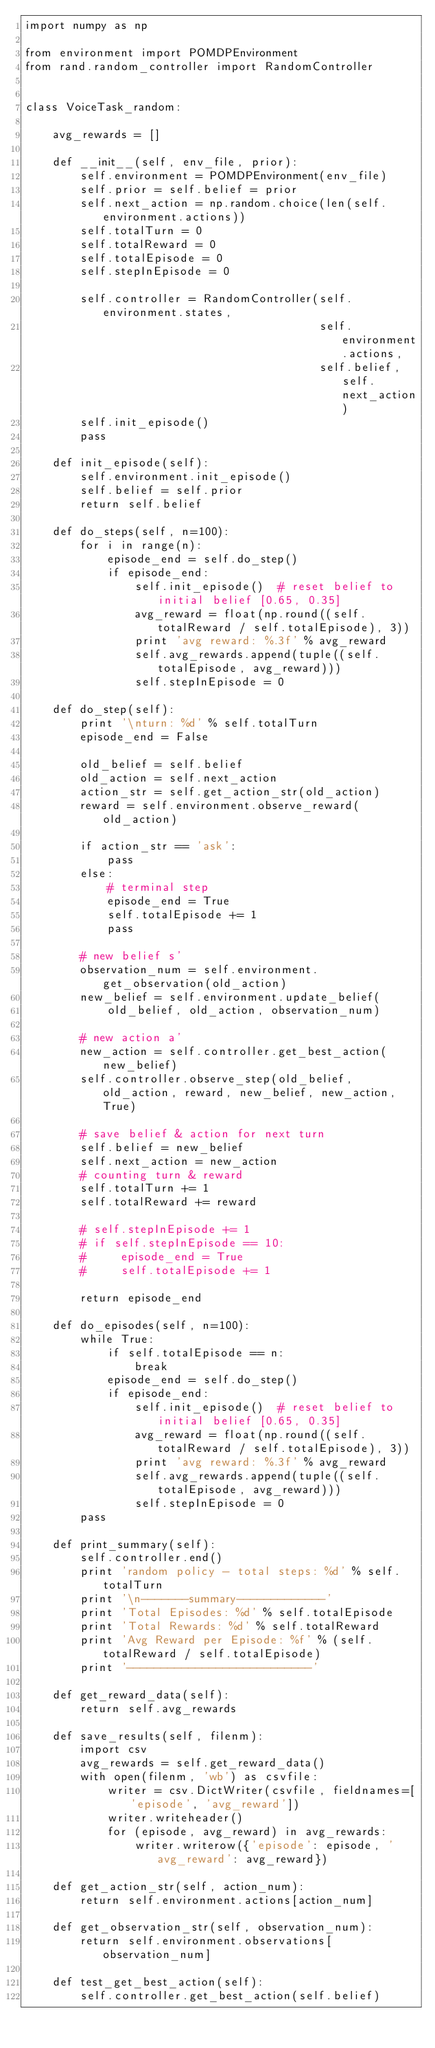Convert code to text. <code><loc_0><loc_0><loc_500><loc_500><_Python_>import numpy as np

from environment import POMDPEnvironment
from rand.random_controller import RandomController


class VoiceTask_random:

    avg_rewards = []

    def __init__(self, env_file, prior):
        self.environment = POMDPEnvironment(env_file)
        self.prior = self.belief = prior
        self.next_action = np.random.choice(len(self.environment.actions))
        self.totalTurn = 0
        self.totalReward = 0
        self.totalEpisode = 0
        self.stepInEpisode = 0

        self.controller = RandomController(self.environment.states,
                                           self.environment.actions,
                                           self.belief, self.next_action)
        self.init_episode()
        pass

    def init_episode(self):
        self.environment.init_episode()
        self.belief = self.prior
        return self.belief

    def do_steps(self, n=100):
        for i in range(n):
            episode_end = self.do_step()
            if episode_end:
                self.init_episode()  # reset belief to initial belief [0.65, 0.35]
                avg_reward = float(np.round((self.totalReward / self.totalEpisode), 3))
                print 'avg reward: %.3f' % avg_reward
                self.avg_rewards.append(tuple((self.totalEpisode, avg_reward)))
                self.stepInEpisode = 0

    def do_step(self):
        print '\nturn: %d' % self.totalTurn
        episode_end = False

        old_belief = self.belief
        old_action = self.next_action
        action_str = self.get_action_str(old_action)
        reward = self.environment.observe_reward(old_action)

        if action_str == 'ask':
            pass
        else:
            # terminal step
            episode_end = True
            self.totalEpisode += 1
            pass

        # new belief s'
        observation_num = self.environment.get_observation(old_action)
        new_belief = self.environment.update_belief(
            old_belief, old_action, observation_num)

        # new action a'
        new_action = self.controller.get_best_action(new_belief)
        self.controller.observe_step(old_belief, old_action, reward, new_belief, new_action, True)

        # save belief & action for next turn
        self.belief = new_belief
        self.next_action = new_action
        # counting turn & reward
        self.totalTurn += 1
        self.totalReward += reward

        # self.stepInEpisode += 1
        # if self.stepInEpisode == 10:
        #     episode_end = True
        #     self.totalEpisode += 1

        return episode_end

    def do_episodes(self, n=100):
        while True:
            if self.totalEpisode == n:
                break
            episode_end = self.do_step()
            if episode_end:
                self.init_episode()  # reset belief to initial belief [0.65, 0.35]
                avg_reward = float(np.round((self.totalReward / self.totalEpisode), 3))
                print 'avg reward: %.3f' % avg_reward
                self.avg_rewards.append(tuple((self.totalEpisode, avg_reward)))
                self.stepInEpisode = 0
        pass

    def print_summary(self):
        self.controller.end()
        print 'random policy - total steps: %d' % self.totalTurn
        print '\n-------summary-------------'
        print 'Total Episodes: %d' % self.totalEpisode
        print 'Total Rewards: %d' % self.totalReward
        print 'Avg Reward per Episode: %f' % (self.totalReward / self.totalEpisode)
        print '---------------------------'

    def get_reward_data(self):
        return self.avg_rewards

    def save_results(self, filenm):
        import csv
        avg_rewards = self.get_reward_data()
        with open(filenm, 'wb') as csvfile:
            writer = csv.DictWriter(csvfile, fieldnames=['episode', 'avg_reward'])
            writer.writeheader()
            for (episode, avg_reward) in avg_rewards:
                writer.writerow({'episode': episode, 'avg_reward': avg_reward})

    def get_action_str(self, action_num):
        return self.environment.actions[action_num]

    def get_observation_str(self, observation_num):
        return self.environment.observations[observation_num]

    def test_get_best_action(self):
        self.controller.get_best_action(self.belief)


</code> 